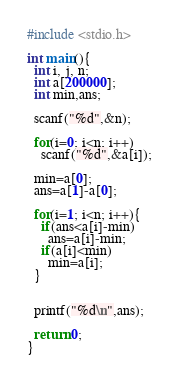<code> <loc_0><loc_0><loc_500><loc_500><_C_>#include <stdio.h>

int main(){
  int i, j, n;
  int a[200000];
  int min,ans;

  scanf("%d",&n);
  
  for(i=0; i<n; i++)
    scanf("%d",&a[i]);

  min=a[0];
  ans=a[1]-a[0];

  for(i=1; i<n; i++){
    if(ans<a[i]-min)
      ans=a[i]-min;
    if(a[i]<min)
      min=a[i];
  }
    
  
  printf("%d\n",ans);

  return 0;
}

</code> 